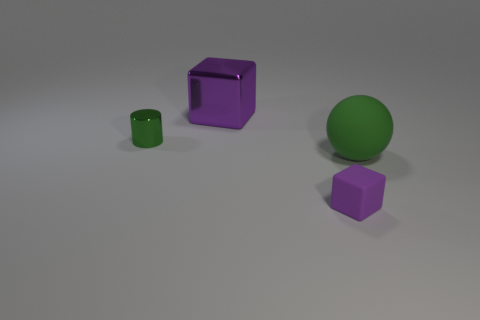Is the size of the purple thing in front of the matte ball the same as the metal thing in front of the big metallic thing?
Offer a terse response. Yes. There is another object that is the same shape as the big shiny thing; what is it made of?
Your answer should be very brief. Rubber. How many tiny things are either red shiny cylinders or purple rubber objects?
Ensure brevity in your answer.  1. What material is the tiny purple thing?
Ensure brevity in your answer.  Rubber. The object that is both in front of the purple metallic object and behind the green matte sphere is made of what material?
Your answer should be very brief. Metal. Do the ball and the object in front of the big rubber sphere have the same color?
Offer a terse response. No. What is the material of the purple cube that is the same size as the cylinder?
Your response must be concise. Rubber. Are there any large blocks that have the same material as the small purple thing?
Make the answer very short. No. What number of cyan metal things are there?
Your response must be concise. 0. Is the large sphere made of the same material as the purple thing that is in front of the cylinder?
Keep it short and to the point. Yes. 